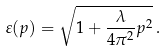Convert formula to latex. <formula><loc_0><loc_0><loc_500><loc_500>\varepsilon ( p ) = \sqrt { 1 + \frac { \lambda } { 4 \pi ^ { 2 } } p ^ { 2 } } \, .</formula> 